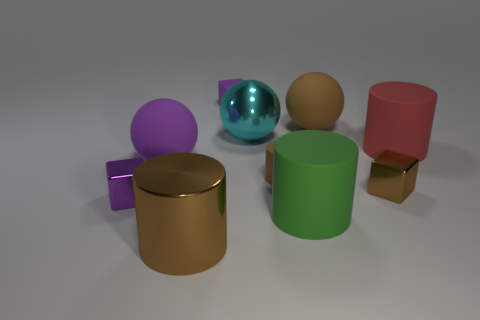Subtract all purple balls. Subtract all gray cylinders. How many balls are left? 2 Subtract all spheres. How many objects are left? 7 Subtract all big cyan rubber objects. Subtract all green objects. How many objects are left? 9 Add 8 large purple objects. How many large purple objects are left? 9 Add 2 tiny red metallic cubes. How many tiny red metallic cubes exist? 2 Subtract 0 purple cylinders. How many objects are left? 10 